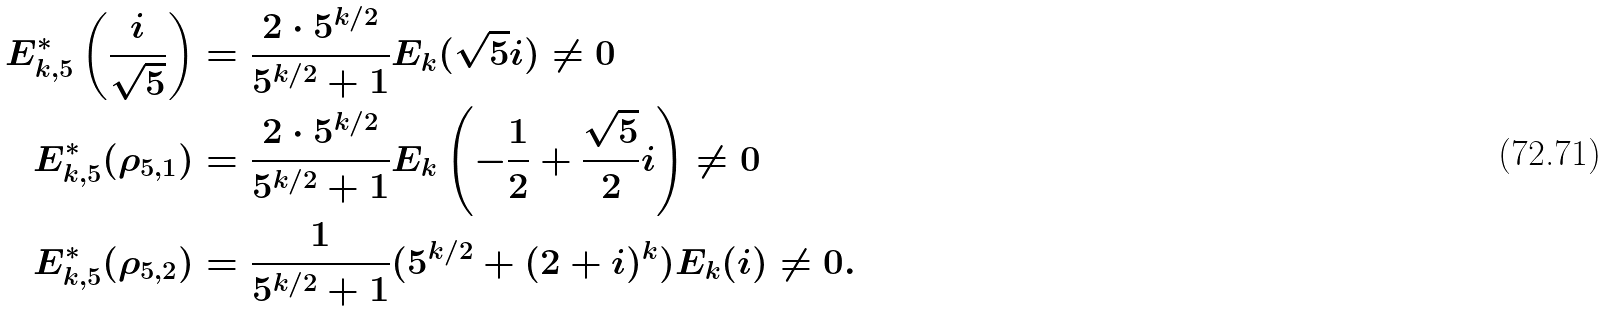<formula> <loc_0><loc_0><loc_500><loc_500>E _ { k , 5 } ^ { * } \left ( \frac { i } { \sqrt { 5 } } \right ) & = \frac { 2 \cdot 5 ^ { k / 2 } } { 5 ^ { k / 2 } + 1 } E _ { k } ( \sqrt { 5 } i ) \ne 0 \\ E _ { k , 5 } ^ { * } ( \rho _ { 5 , 1 } ) & = \frac { 2 \cdot 5 ^ { k / 2 } } { 5 ^ { k / 2 } + 1 } E _ { k } \left ( - \frac { 1 } { 2 } + \frac { \sqrt { 5 } } { 2 } i \right ) \ne 0 \\ E _ { k , 5 } ^ { * } ( \rho _ { 5 , 2 } ) & = \frac { 1 } { 5 ^ { k / 2 } + 1 } ( 5 ^ { k / 2 } + ( 2 + i ) ^ { k } ) E _ { k } ( i ) \ne 0 .</formula> 